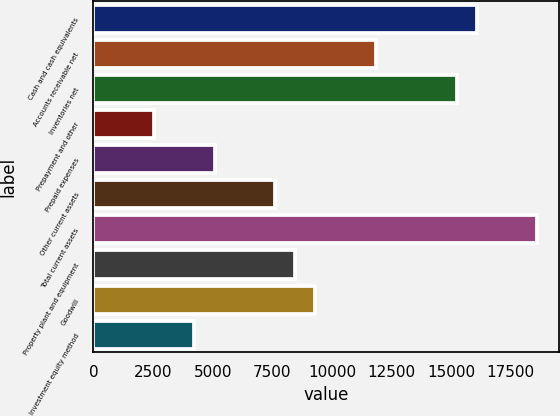Convert chart. <chart><loc_0><loc_0><loc_500><loc_500><bar_chart><fcel>Cash and cash equivalents<fcel>Accounts receivable net<fcel>Inventories net<fcel>Prepayment and other<fcel>Prepaid expenses<fcel>Other current assets<fcel>Total current assets<fcel>Property plant and equipment<fcel>Goodwill<fcel>Investment equity method<nl><fcel>16076.2<fcel>11847.2<fcel>15230.4<fcel>2543.4<fcel>5080.8<fcel>7618.2<fcel>18613.6<fcel>8464<fcel>9309.8<fcel>4235<nl></chart> 